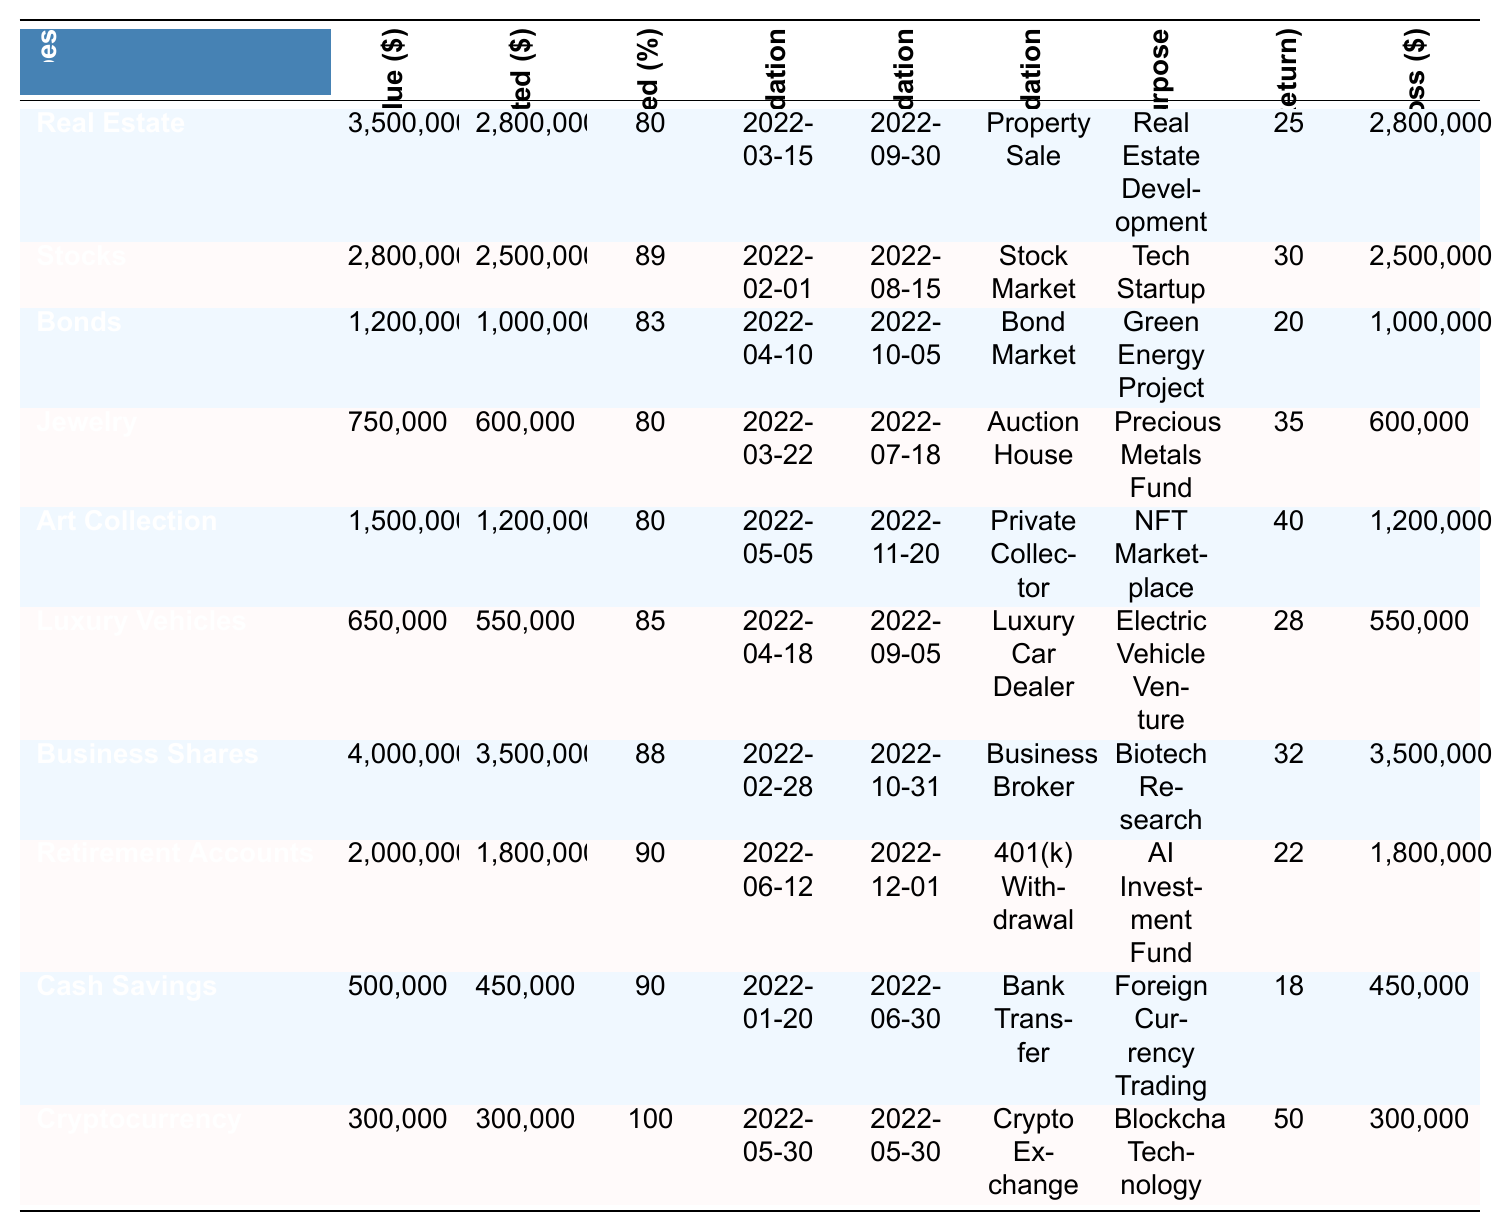What is the total amount liquidated from all assets? By summing the "Amount Liquidated" values: 2,800,000 + 2,500,000 + 1,000,000 + 600,000 + 1,200,000 + 550,000 + 3,500,000 + 1,800,000 + 450,000 + 300,000 = 14,650,000
Answer: 14,650,000 Which asset type had the highest percentage liquidated? The highest percentage liquidated is found under "Cryptocurrency" at 100%.
Answer: Cryptocurrency What was the initial value of the Luxury Vehicles? The initial value for Luxury Vehicles is listed as 650,000.
Answer: 650,000 Which asset type had the lowest actual loss? By examining the "Actual Loss" column, the lowest value of 300,000 corresponds to "Cryptocurrency."
Answer: Cryptocurrency What is the average percentage liquidated across all assets? To find the average, add all percentages: (80 + 89 + 83 + 80 + 80 + 85 + 88 + 90 + 90 + 100) =  885, and then divide by 10 (number of asset types), which gives 88.5%.
Answer: 88.5 Did the businesswoman liquidate more cash savings or jewelry? Cash savings amount to 450,000, while jewelry amounts to 600,000. Since 450,000 < 600,000, she liquidated less cash savings than jewelry.
Answer: No Which asset type had the most significant promised return and what was that return? The asset type with the highest promised return is "Cryptocurrency" at 50%.
Answer: Cryptocurrency, 50% How many asset types had more than 80% of their initial value liquidated? Counting those with over 80%: Real Estate (80%), Stocks (89%), Bonds (83%), Jewelry (80%), Art Collection (80%), Luxury Vehicles (85%), Business Shares (88%), Retirement Accounts (90%), Cash Savings (90%), Cryptocurrency (100) gives a total of 10.
Answer: 10 What method of liquidation was used for selling the highest value asset? The highest value asset is "Business Shares," which was liquidated through a "Business Broker."
Answer: Business Broker What is the total actual loss incurred on the stocks and bonds combined? Stocks have an actual loss of 2,500,000 and bonds have an actual loss of 1,000,000. Adding these: 2,500,000 + 1,000,000 = 3,500,000.
Answer: 3,500,000 